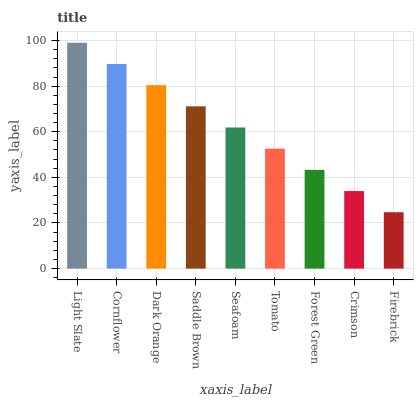Is Firebrick the minimum?
Answer yes or no. Yes. Is Light Slate the maximum?
Answer yes or no. Yes. Is Cornflower the minimum?
Answer yes or no. No. Is Cornflower the maximum?
Answer yes or no. No. Is Light Slate greater than Cornflower?
Answer yes or no. Yes. Is Cornflower less than Light Slate?
Answer yes or no. Yes. Is Cornflower greater than Light Slate?
Answer yes or no. No. Is Light Slate less than Cornflower?
Answer yes or no. No. Is Seafoam the high median?
Answer yes or no. Yes. Is Seafoam the low median?
Answer yes or no. Yes. Is Dark Orange the high median?
Answer yes or no. No. Is Firebrick the low median?
Answer yes or no. No. 